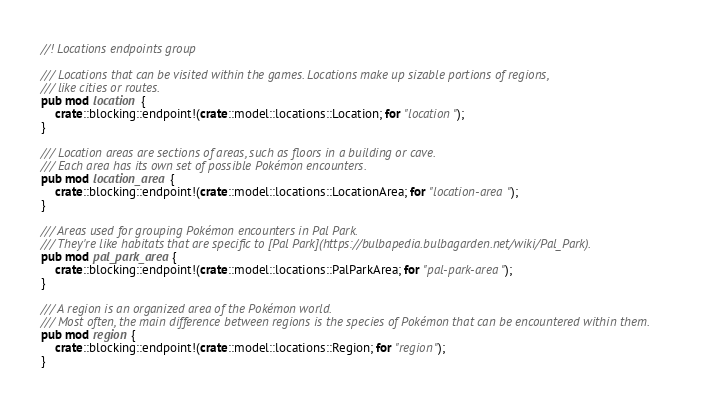Convert code to text. <code><loc_0><loc_0><loc_500><loc_500><_Rust_>//! Locations endpoints group

/// Locations that can be visited within the games. Locations make up sizable portions of regions,
/// like cities or routes.
pub mod location {
    crate::blocking::endpoint!(crate::model::locations::Location; for "location");
}

/// Location areas are sections of areas, such as floors in a building or cave.
/// Each area has its own set of possible Pokémon encounters.
pub mod location_area {
    crate::blocking::endpoint!(crate::model::locations::LocationArea; for "location-area");
}

/// Areas used for grouping Pokémon encounters in Pal Park.
/// They're like habitats that are specific to [Pal Park](https://bulbapedia.bulbagarden.net/wiki/Pal_Park).
pub mod pal_park_area {
    crate::blocking::endpoint!(crate::model::locations::PalParkArea; for "pal-park-area");
}

/// A region is an organized area of the Pokémon world.
/// Most often, the main difference between regions is the species of Pokémon that can be encountered within them.
pub mod region {
    crate::blocking::endpoint!(crate::model::locations::Region; for "region");
}
</code> 